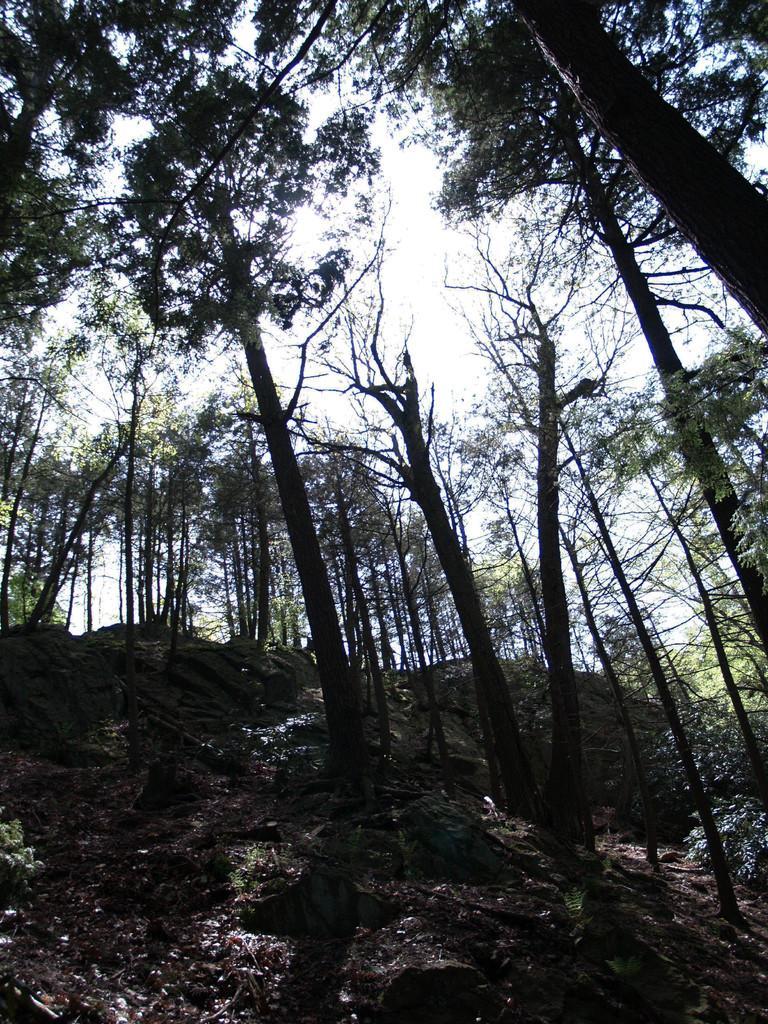In one or two sentences, can you explain what this image depicts? In this picture we can see the ground, rocks, trees and in the background we can see the sky. 